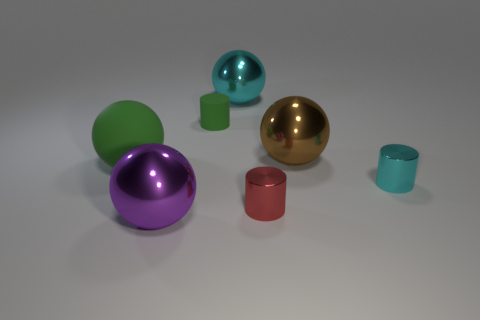Can you tell me which objects have a reflective surface? Certainly! The purple, green, and golden spheres, along with the turquoise small cylinder, have reflective surfaces that generate distinct highlights and clear reflections of their surroundings. 